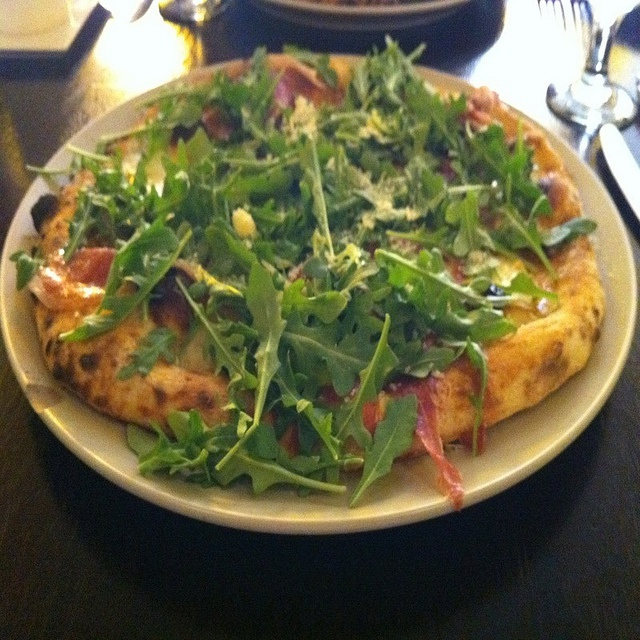Describe the objects in this image and their specific colors. I can see dining table in black, darkgreen, olive, gray, and white tones, pizza in tan, darkgreen, olive, and brown tones, and spoon in tan, white, darkgray, gray, and lightgray tones in this image. 